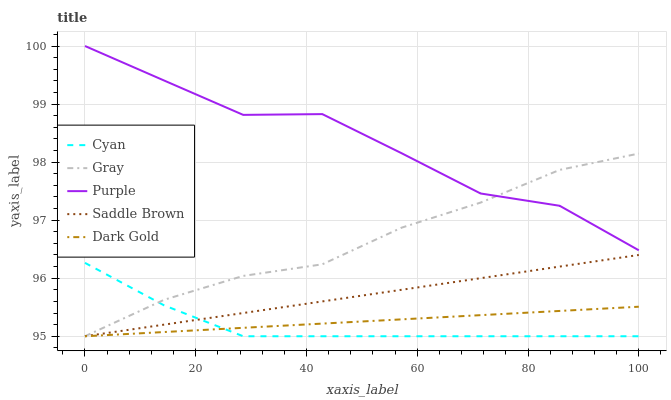Does Cyan have the minimum area under the curve?
Answer yes or no. Yes. Does Purple have the maximum area under the curve?
Answer yes or no. Yes. Does Dark Gold have the minimum area under the curve?
Answer yes or no. No. Does Dark Gold have the maximum area under the curve?
Answer yes or no. No. Is Saddle Brown the smoothest?
Answer yes or no. Yes. Is Purple the roughest?
Answer yes or no. Yes. Is Cyan the smoothest?
Answer yes or no. No. Is Cyan the roughest?
Answer yes or no. No. Does Cyan have the lowest value?
Answer yes or no. Yes. Does Purple have the highest value?
Answer yes or no. Yes. Does Cyan have the highest value?
Answer yes or no. No. Is Cyan less than Purple?
Answer yes or no. Yes. Is Purple greater than Saddle Brown?
Answer yes or no. Yes. Does Saddle Brown intersect Dark Gold?
Answer yes or no. Yes. Is Saddle Brown less than Dark Gold?
Answer yes or no. No. Is Saddle Brown greater than Dark Gold?
Answer yes or no. No. Does Cyan intersect Purple?
Answer yes or no. No. 